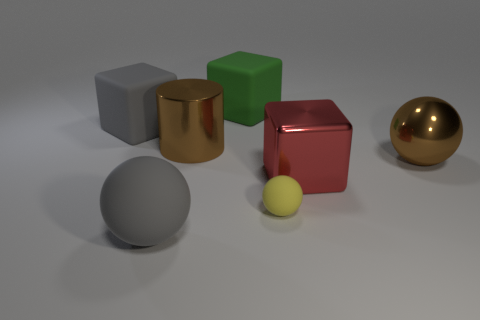Add 1 large matte blocks. How many objects exist? 8 Subtract all large matte spheres. How many spheres are left? 2 Subtract all gray cubes. How many cubes are left? 2 Subtract 1 red blocks. How many objects are left? 6 Subtract all cylinders. How many objects are left? 6 Subtract 1 cylinders. How many cylinders are left? 0 Subtract all cyan spheres. Subtract all red cubes. How many spheres are left? 3 Subtract all red balls. How many cyan cylinders are left? 0 Subtract all large brown metal objects. Subtract all large balls. How many objects are left? 3 Add 2 large rubber balls. How many large rubber balls are left? 3 